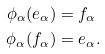Convert formula to latex. <formula><loc_0><loc_0><loc_500><loc_500>\phi _ { \alpha } ( e _ { \alpha } ) & = f _ { \alpha } \\ \phi _ { \alpha } ( f _ { \alpha } ) & = e _ { \alpha } .</formula> 